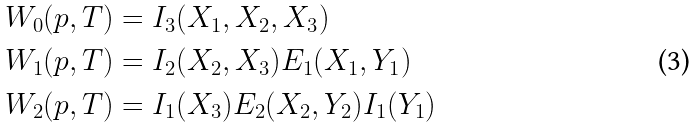Convert formula to latex. <formula><loc_0><loc_0><loc_500><loc_500>W _ { 0 } ( p , T ) & = I _ { 3 } ( X _ { 1 } , X _ { 2 } , X _ { 3 } ) \\ W _ { 1 } ( p , T ) & = I _ { 2 } ( X _ { 2 } , X _ { 3 } ) E _ { 1 } ( X _ { 1 } , Y _ { 1 } ) \\ W _ { 2 } ( p , T ) & = I _ { 1 } ( X _ { 3 } ) E _ { 2 } ( X _ { 2 } , Y _ { 2 } ) I _ { 1 } ( Y _ { 1 } )</formula> 